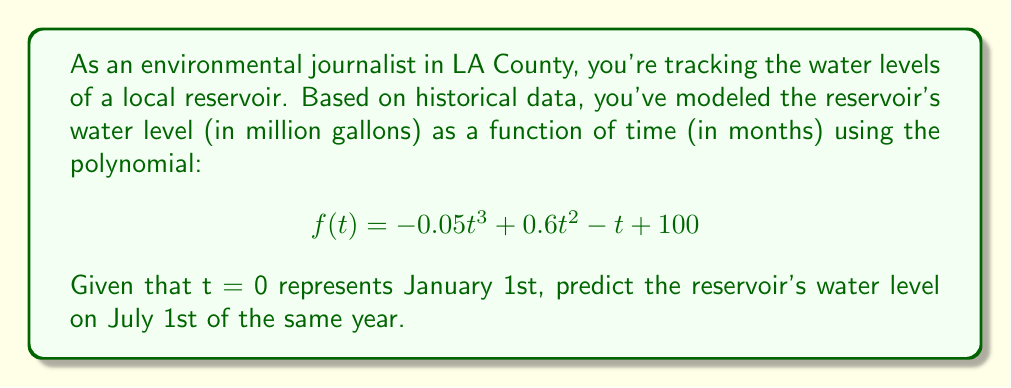Help me with this question. To solve this problem, we'll follow these steps:

1. Identify the value of t for July 1st:
   July 1st is 6 months after January 1st, so t = 6.

2. Substitute t = 6 into the given polynomial function:
   $$f(6) = -0.05(6)^3 + 0.6(6)^2 - 6 + 100$$

3. Calculate each term:
   $$f(6) = -0.05(216) + 0.6(36) - 6 + 100$$
   $$f(6) = -10.8 + 21.6 - 6 + 100$$

4. Sum up the terms:
   $$f(6) = 104.8$$

Therefore, the predicted water level on July 1st is 104.8 million gallons.
Answer: 104.8 million gallons 